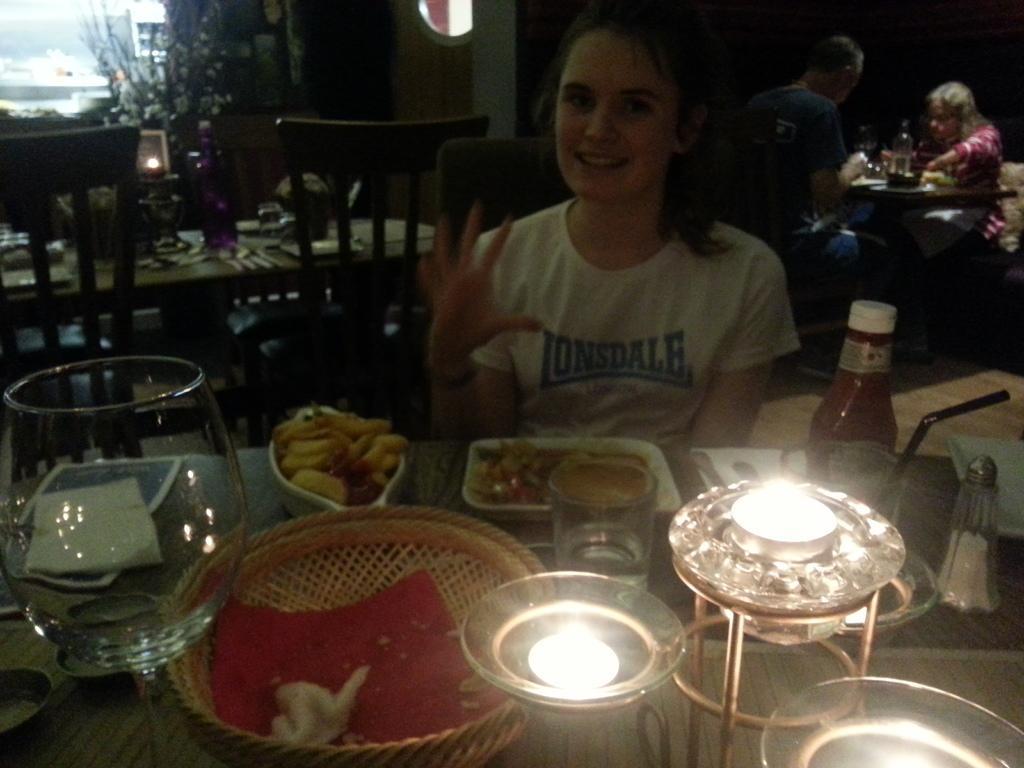In one or two sentences, can you explain what this image depicts? These three persons are sitting on the chair. This is table. On the table we can see bowl,plate,basket,glass,lamp,ketchup bottle,food. On the background we can see wall,plant. 